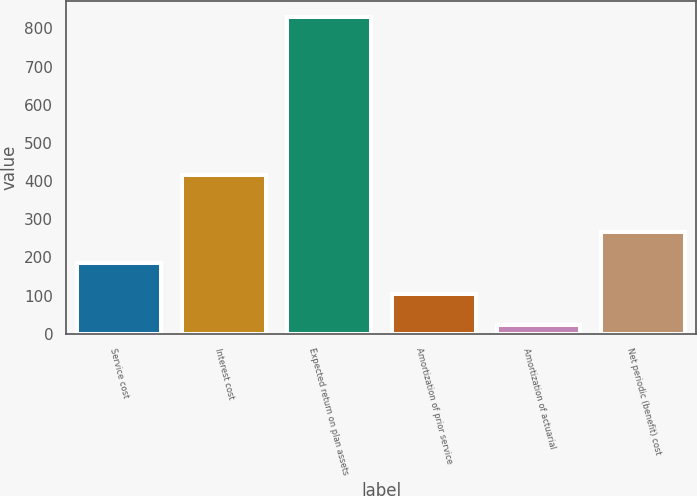<chart> <loc_0><loc_0><loc_500><loc_500><bar_chart><fcel>Service cost<fcel>Interest cost<fcel>Expected return on plan assets<fcel>Amortization of prior service<fcel>Amortization of actuarial<fcel>Net periodic (benefit) cost<nl><fcel>184.6<fcel>416<fcel>831<fcel>103.8<fcel>23<fcel>265.4<nl></chart> 